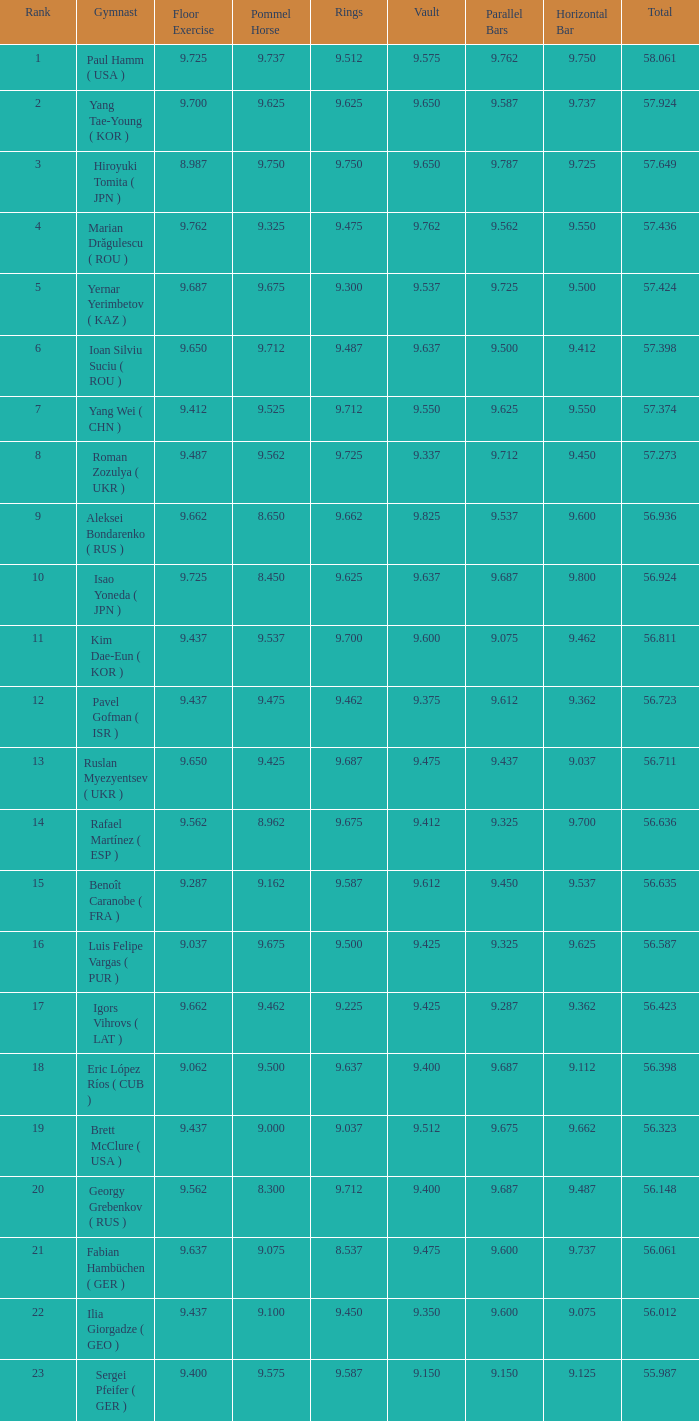What is the vault score for the total of 56.635? 9.612. Could you help me parse every detail presented in this table? {'header': ['Rank', 'Gymnast', 'Floor Exercise', 'Pommel Horse', 'Rings', 'Vault', 'Parallel Bars', 'Horizontal Bar', 'Total'], 'rows': [['1', 'Paul Hamm ( USA )', '9.725', '9.737', '9.512', '9.575', '9.762', '9.750', '58.061'], ['2', 'Yang Tae-Young ( KOR )', '9.700', '9.625', '9.625', '9.650', '9.587', '9.737', '57.924'], ['3', 'Hiroyuki Tomita ( JPN )', '8.987', '9.750', '9.750', '9.650', '9.787', '9.725', '57.649'], ['4', 'Marian Drăgulescu ( ROU )', '9.762', '9.325', '9.475', '9.762', '9.562', '9.550', '57.436'], ['5', 'Yernar Yerimbetov ( KAZ )', '9.687', '9.675', '9.300', '9.537', '9.725', '9.500', '57.424'], ['6', 'Ioan Silviu Suciu ( ROU )', '9.650', '9.712', '9.487', '9.637', '9.500', '9.412', '57.398'], ['7', 'Yang Wei ( CHN )', '9.412', '9.525', '9.712', '9.550', '9.625', '9.550', '57.374'], ['8', 'Roman Zozulya ( UKR )', '9.487', '9.562', '9.725', '9.337', '9.712', '9.450', '57.273'], ['9', 'Aleksei Bondarenko ( RUS )', '9.662', '8.650', '9.662', '9.825', '9.537', '9.600', '56.936'], ['10', 'Isao Yoneda ( JPN )', '9.725', '8.450', '9.625', '9.637', '9.687', '9.800', '56.924'], ['11', 'Kim Dae-Eun ( KOR )', '9.437', '9.537', '9.700', '9.600', '9.075', '9.462', '56.811'], ['12', 'Pavel Gofman ( ISR )', '9.437', '9.475', '9.462', '9.375', '9.612', '9.362', '56.723'], ['13', 'Ruslan Myezyentsev ( UKR )', '9.650', '9.425', '9.687', '9.475', '9.437', '9.037', '56.711'], ['14', 'Rafael Martínez ( ESP )', '9.562', '8.962', '9.675', '9.412', '9.325', '9.700', '56.636'], ['15', 'Benoît Caranobe ( FRA )', '9.287', '9.162', '9.587', '9.612', '9.450', '9.537', '56.635'], ['16', 'Luis Felipe Vargas ( PUR )', '9.037', '9.675', '9.500', '9.425', '9.325', '9.625', '56.587'], ['17', 'Igors Vihrovs ( LAT )', '9.662', '9.462', '9.225', '9.425', '9.287', '9.362', '56.423'], ['18', 'Eric López Ríos ( CUB )', '9.062', '9.500', '9.637', '9.400', '9.687', '9.112', '56.398'], ['19', 'Brett McClure ( USA )', '9.437', '9.000', '9.037', '9.512', '9.675', '9.662', '56.323'], ['20', 'Georgy Grebenkov ( RUS )', '9.562', '8.300', '9.712', '9.400', '9.687', '9.487', '56.148'], ['21', 'Fabian Hambüchen ( GER )', '9.637', '9.075', '8.537', '9.475', '9.600', '9.737', '56.061'], ['22', 'Ilia Giorgadze ( GEO )', '9.437', '9.100', '9.450', '9.350', '9.600', '9.075', '56.012'], ['23', 'Sergei Pfeifer ( GER )', '9.400', '9.575', '9.587', '9.150', '9.150', '9.125', '55.987']]} 